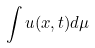<formula> <loc_0><loc_0><loc_500><loc_500>\int u ( x , t ) d \mu</formula> 